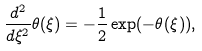<formula> <loc_0><loc_0><loc_500><loc_500>\frac { d ^ { 2 } } { d \xi ^ { 2 } } \theta ( \xi ) = - \frac { 1 } { 2 } \exp ( - \theta ( \xi ) ) ,</formula> 